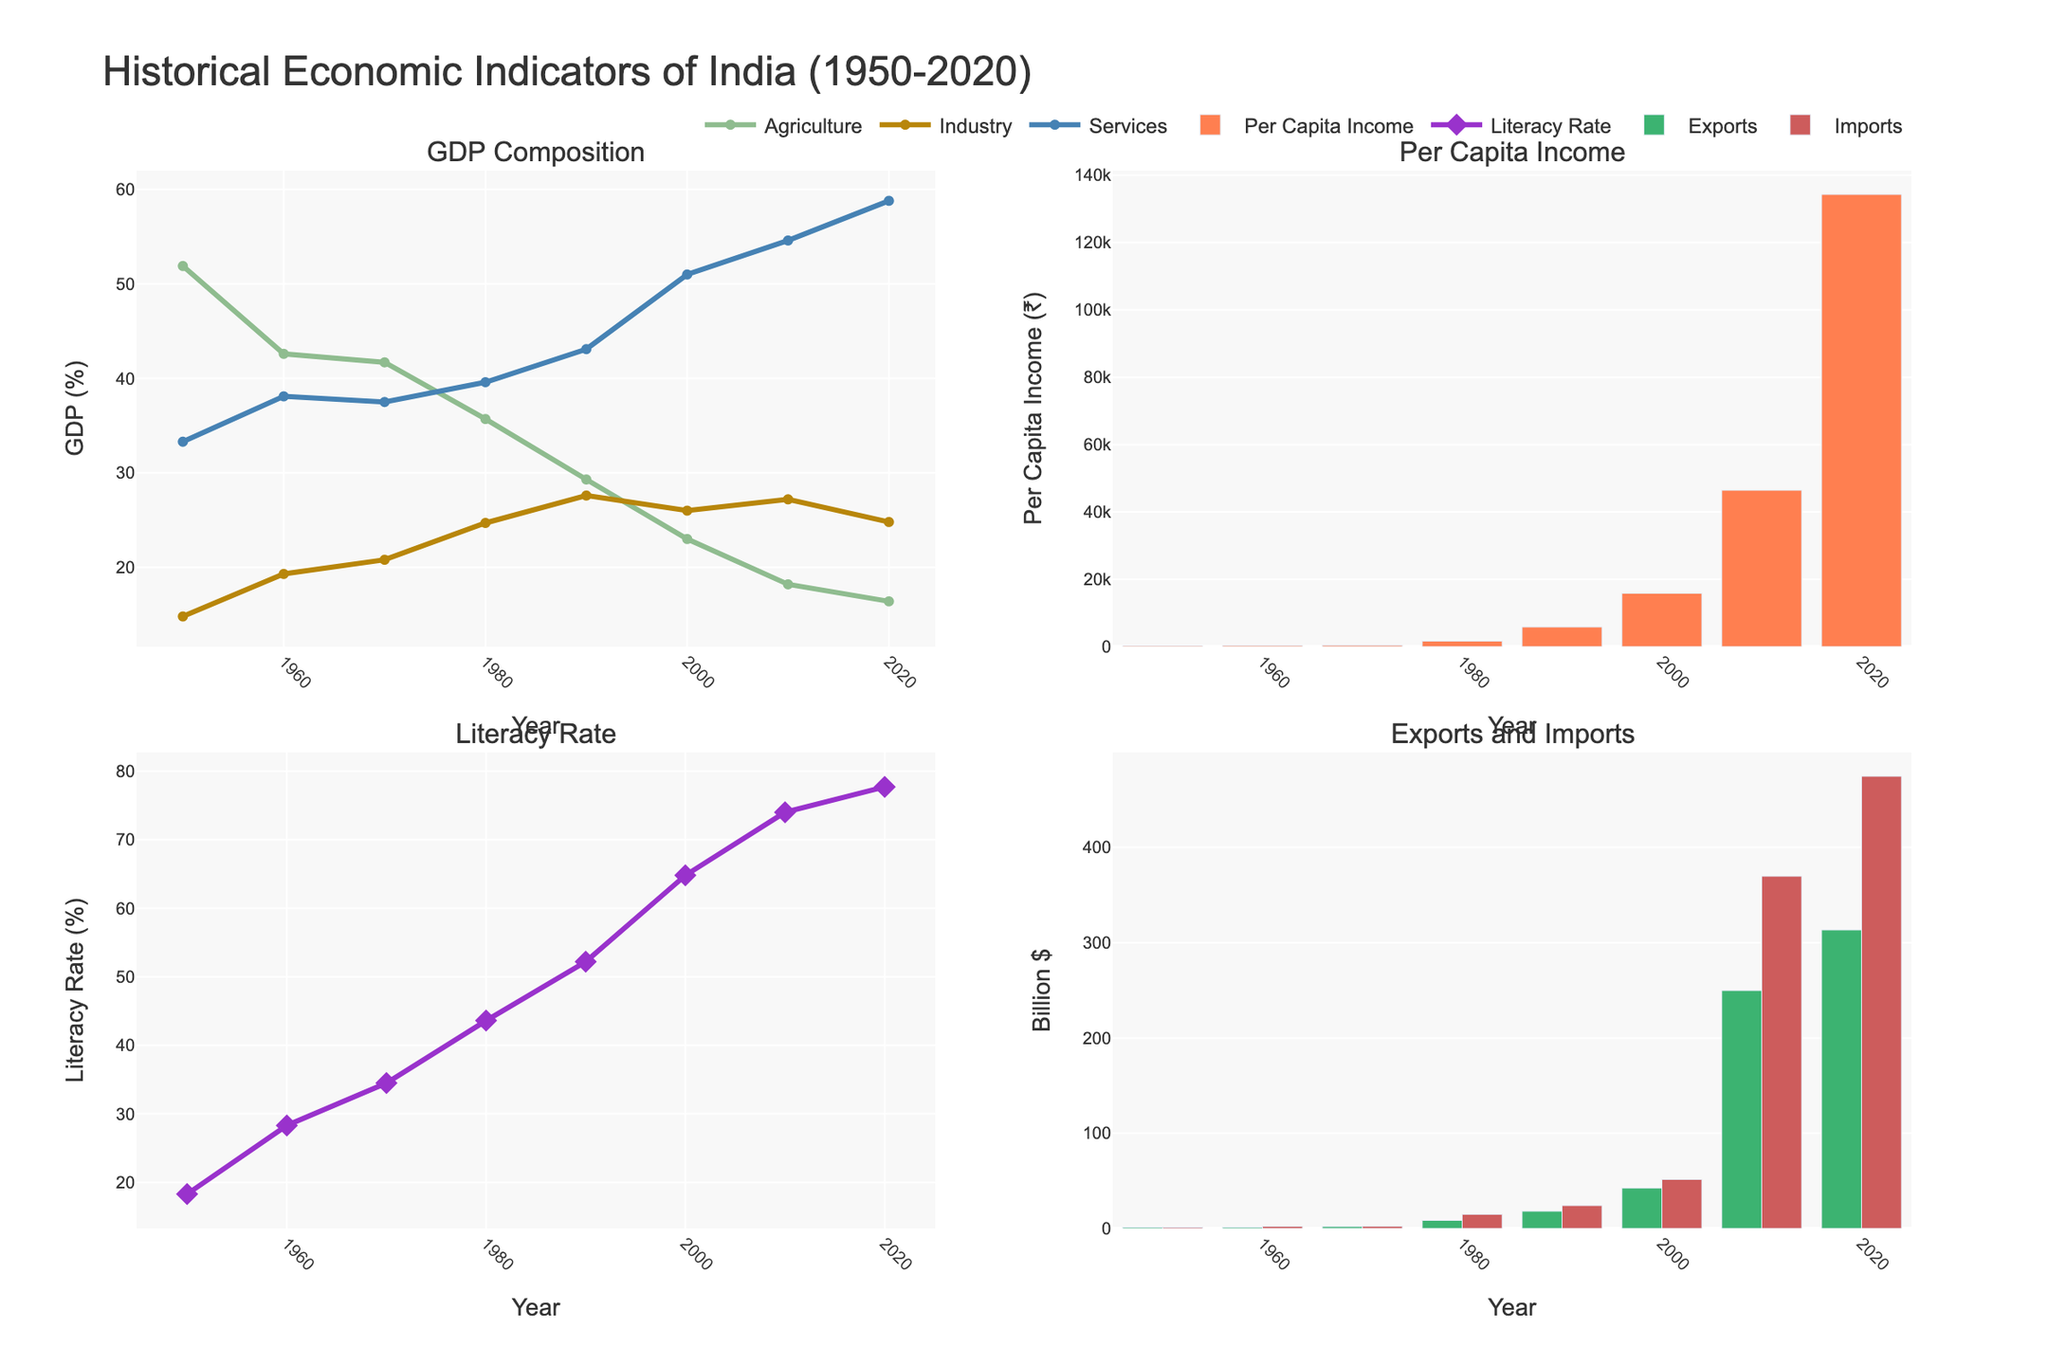What is the title of the figure? The title of the figure is written at the top center of the plot. It reads "Historical Economic Indicators of India (1950-2020)".
Answer: Historical Economic Indicators of India (1950-2020) Which sector had the highest GDP percentage in 2020? Looking at the sub-plot for GDP composition in 2020, the 'Services' sector has the highest GDP percentage, indicated by the blue line reaching around 58.8%.
Answer: Services How has the Per Capita Income changed from 1950 to 2020? Observing the bar sub-plot for Per Capita Income, there is a significant increase from ₹265 in 1950 to ₹134300 in 2020.
Answer: Increased significantly What is the overall trend in India's literacy rate from 1950 to 2020? In the Literacy Rate sub-plot, the line shows a consistent upward trend from around 18.3% in 1950 to 77.7% in 2020.
Answer: Consistent upward trend In which decade did industry GDP percentage surpass agriculture GDP percentage? Referring to the GDP composition sub-plot, Industry GDP percentage (yellow line) first surpasses Agriculture GDP percentage (green line) in the decade of the 1990s.
Answer: 1990s What was the difference between Exports and Imports in 2010? From the Exports and Imports sub-plot, the Export value for 2010 is around $249.8 billion and the Import value is around $369.8 billion. The difference is $369.8 billion - $249.8 billion = $120 billion.
Answer: $120 billion Which year shows the highest Per Capita Income? The bar sub-plot for Per Capita Income shows that 2020 has the tallest bar, indicating the highest Per Capita Income at ₹134300.
Answer: 2020 Compare the GDP percentage of Agriculture, Industry, and Services in 1950. Which sector had the least contribution? In 1950, the GDP composition sub-plot shows Agriculture at 51.9%, Industry at 14.8%, and Services at 33.3%. Industry had the least contribution at 14.8%.
Answer: Industry What is the trend of the Agriculture GDP percentage from 1950 to 2020? From the GDP composition sub-plot, the Agriculture GDP percentage shows a continuous decline from 51.9% in 1950 to 16.4% in 2020.
Answer: Continuous decline 